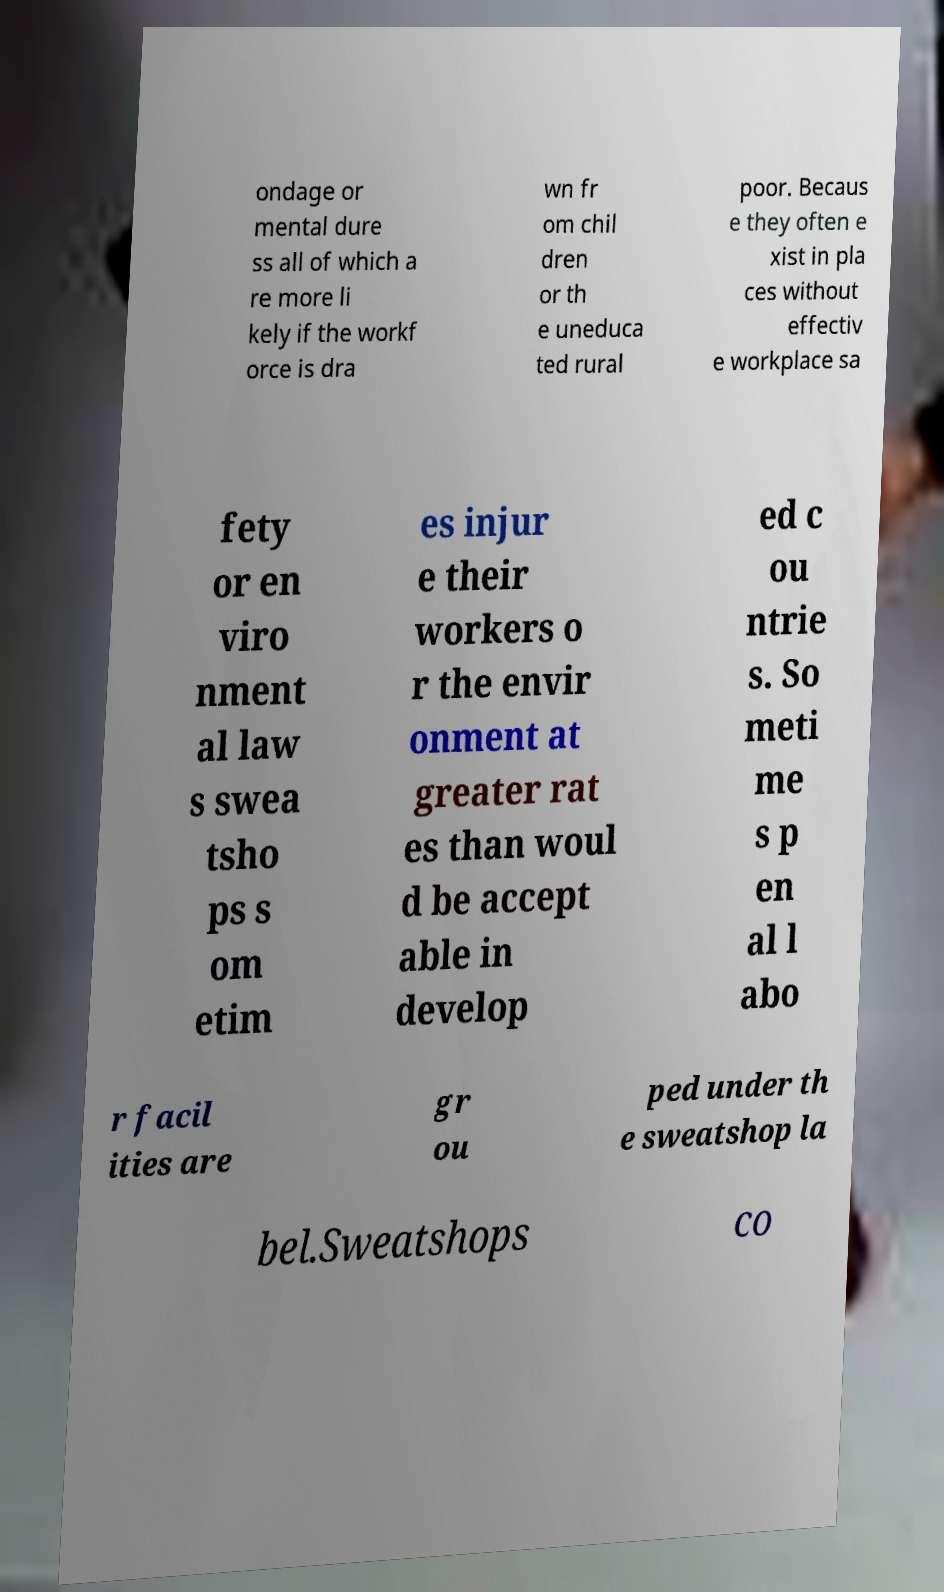Please read and relay the text visible in this image. What does it say? ondage or mental dure ss all of which a re more li kely if the workf orce is dra wn fr om chil dren or th e uneduca ted rural poor. Becaus e they often e xist in pla ces without effectiv e workplace sa fety or en viro nment al law s swea tsho ps s om etim es injur e their workers o r the envir onment at greater rat es than woul d be accept able in develop ed c ou ntrie s. So meti me s p en al l abo r facil ities are gr ou ped under th e sweatshop la bel.Sweatshops co 